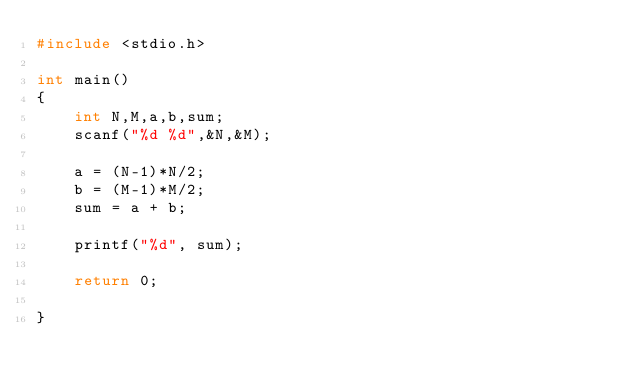<code> <loc_0><loc_0><loc_500><loc_500><_C++_>#include <stdio.h>

int main()
{
    int N,M,a,b,sum;
    scanf("%d %d",&N,&M);

    a = (N-1)*N/2;
    b = (M-1)*M/2;
    sum = a + b;

    printf("%d", sum);

    return 0;

}</code> 